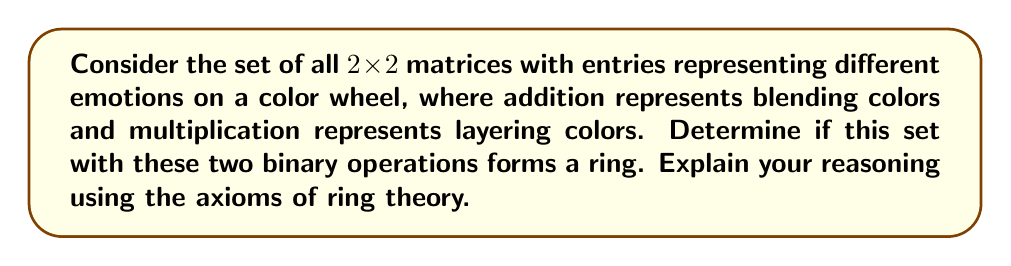Help me with this question. To determine if the given set with the two binary operations forms a ring, we need to check if it satisfies all the ring axioms. Let's go through them step by step:

1. Closure under addition:
   The blending of colors always results in another color on the color wheel, so the set is closed under addition.

2. Associativity of addition:
   $$(A + B) + C = A + (B + C)$$
   Blending colors is associative, so this axiom holds.

3. Commutativity of addition:
   $$A + B = B + A$$
   The order of blending colors doesn't matter, so addition is commutative.

4. Existence of additive identity:
   The matrix with all entries as the "neutral" color (e.g., white) serves as the additive identity.

5. Existence of additive inverse:
   For each color, there exists a complementary color that, when blended, results in the neutral color. So, each matrix has an additive inverse.

6. Closure under multiplication:
   Layering colors always results in another color, so the set is closed under multiplication.

7. Associativity of multiplication:
   $$(A \cdot B) \cdot C = A \cdot (B \cdot C)$$
   Layering colors is associative, so this axiom holds.

8. Distributivity:
   $$A \cdot (B + C) = A \cdot B + A \cdot C$$
   $$(B + C) \cdot A = B \cdot A + C \cdot A$$
   Layering a color over blended colors is equivalent to layering it over each color separately and then blending, so distributivity holds.

However, there are two issues:

1. Existence of multiplicative identity:
   There is no 2x2 matrix that, when used to layer colors, leaves all other matrices unchanged. The identity matrix would need to have a "transparent" color, which is not part of our color wheel.

2. Commutativity of multiplication:
   $$A \cdot B \neq B \cdot A$$ (in general)
   The order of layering colors matters, so multiplication is not commutative.
Answer: The given set with the two binary operations does not form a ring. While it satisfies most ring axioms, it fails to have a multiplicative identity and multiplication is not commutative. Therefore, it forms a non-unital ring-like structure but not a proper ring. 